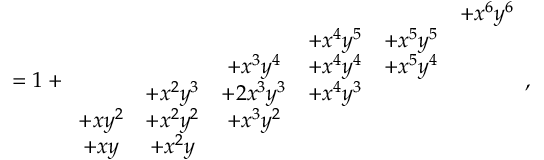Convert formula to latex. <formula><loc_0><loc_0><loc_500><loc_500>= 1 + \begin{array} { c c c c c c } & & & & & { + x ^ { 6 } y ^ { 6 } } \\ & & & { + x ^ { 4 } y ^ { 5 } } & { + x ^ { 5 } y ^ { 5 } } & \\ & & { + x ^ { 3 } y ^ { 4 } } & { + x ^ { 4 } y ^ { 4 } } & { + x ^ { 5 } y ^ { 4 } } & \\ & { + x ^ { 2 } y ^ { 3 } } & { + 2 x ^ { 3 } y ^ { 3 } } & { + x ^ { 4 } y ^ { 3 } } & & \\ { + x y ^ { 2 } } & { + x ^ { 2 } y ^ { 2 } } & { + x ^ { 3 } y ^ { 2 } } & & & \\ { + x y } & { + x ^ { 2 } y } & & & & \end{array} ,</formula> 